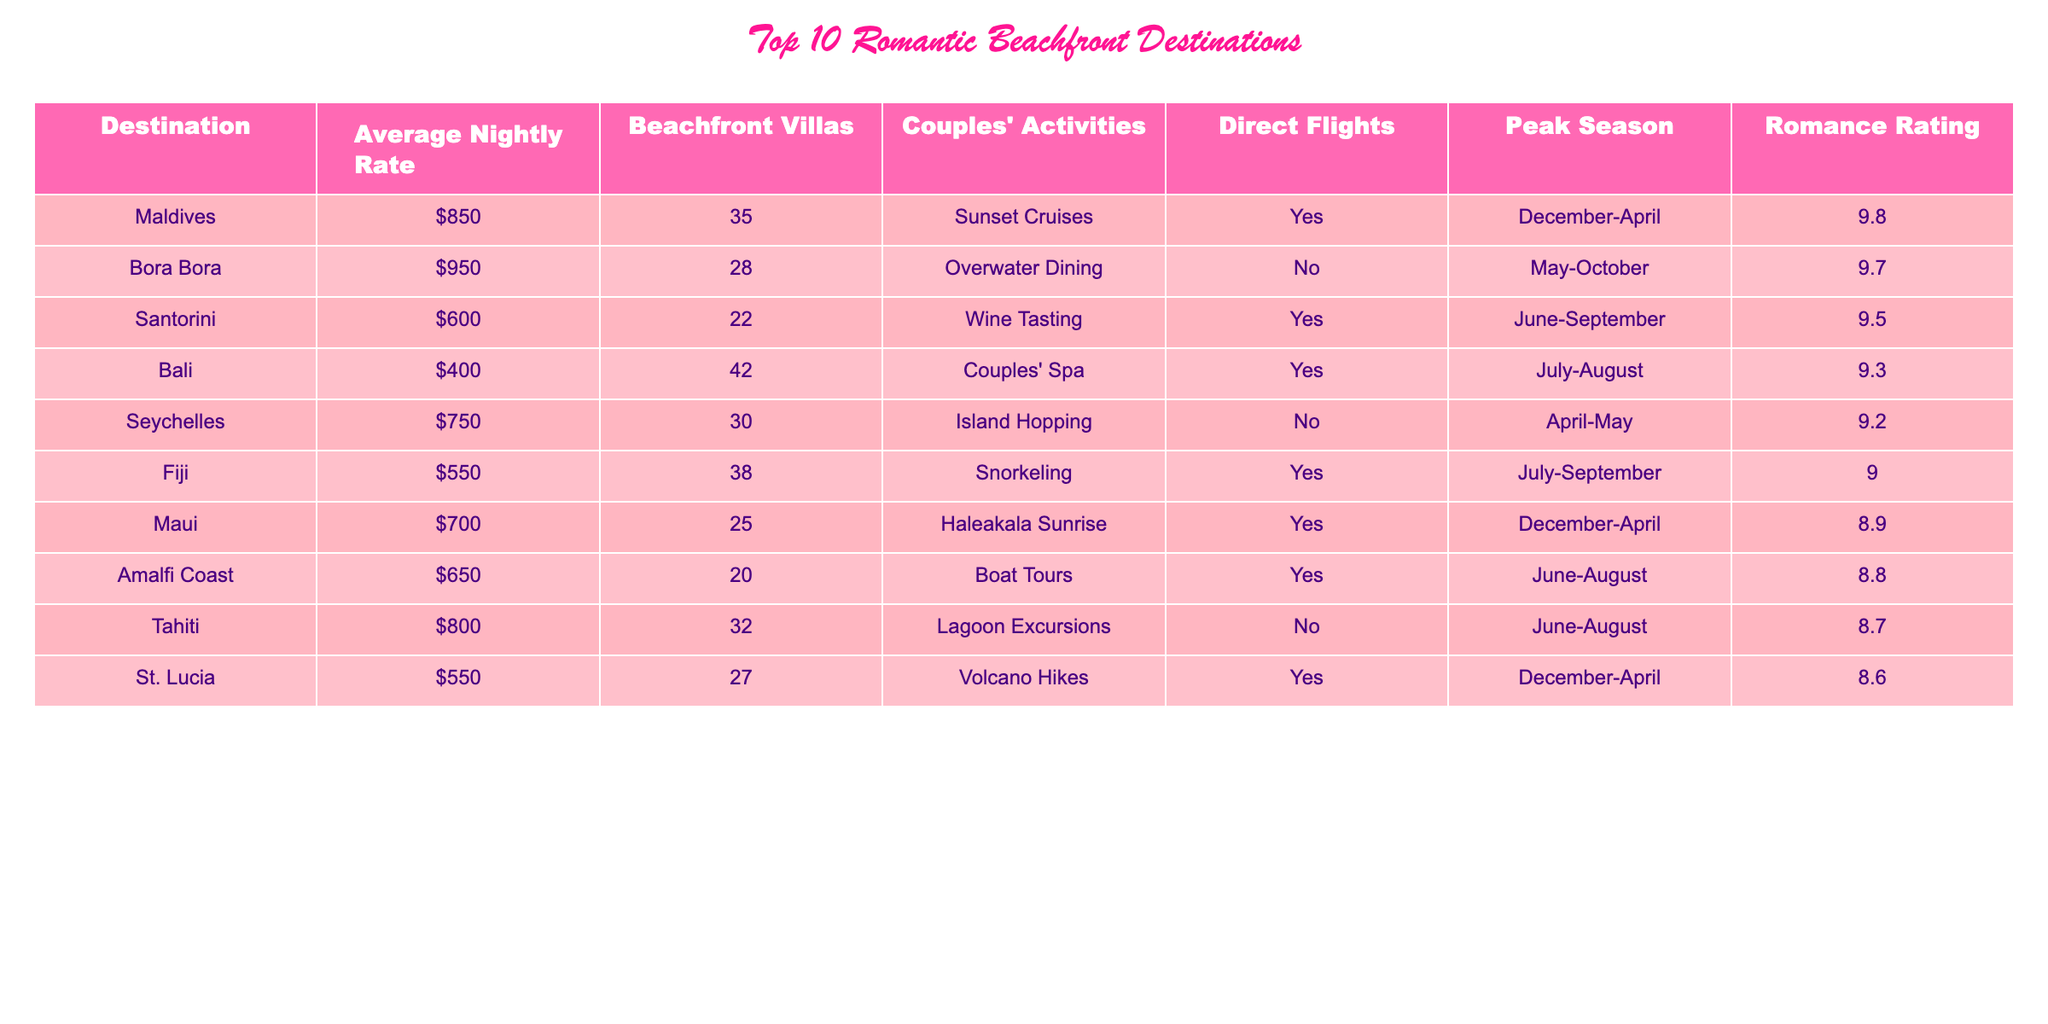What is the average nightly rate for Santorini? The table shows that the average nightly rate for Santorini is listed as $600.
Answer: $600 How many beachfront villas are available in Fiji? According to the table, Fiji has 38 beachfront villas available.
Answer: 38 Which destination has the highest romance rating? By comparing the romance ratings in the table, the Maldives has the highest rating at 9.8.
Answer: Maldives Are there direct flights to Bora Bora? The table states that there are no direct flights available to Bora Bora.
Answer: No What is the total number of beachfront villas in the top three destinations? The top three destinations are the Maldives (35 villas), Bora Bora (28 villas), and Santorini (22 villas). Adding these gives 35 + 28 + 22 = 85 villas in total.
Answer: 85 Which destination has the lowest average nightly rate and what is the rate? The destination with the lowest average nightly rate is Bali, which is $400.
Answer: Bali, $400 Which two destinations have the same peak seasons, and what are those months? Bali and St. Lucia both have their peak seasons from December to April.
Answer: Bali and St. Lucia, December-April How does the romance rating of Fiji compare to that of Tahiti? Fiji has a romance rating of 9.0, while Tahiti has a rating of 8.7. Since 9.0 is greater than 8.7, Fiji's rating is higher.
Answer: Fiji is higher What percentage of the chosen destinations provide couples' activities? There are 10 destinations listed, out of which 7 offer couples' activities. Thus, the percentage is (7/10) * 100 = 70%.
Answer: 70% Which destination has the most couples' activities available and what are they? Bali offers the most couples' activities with a 'Couples’ Spa'.
Answer: Bali, Couples’ Spa 